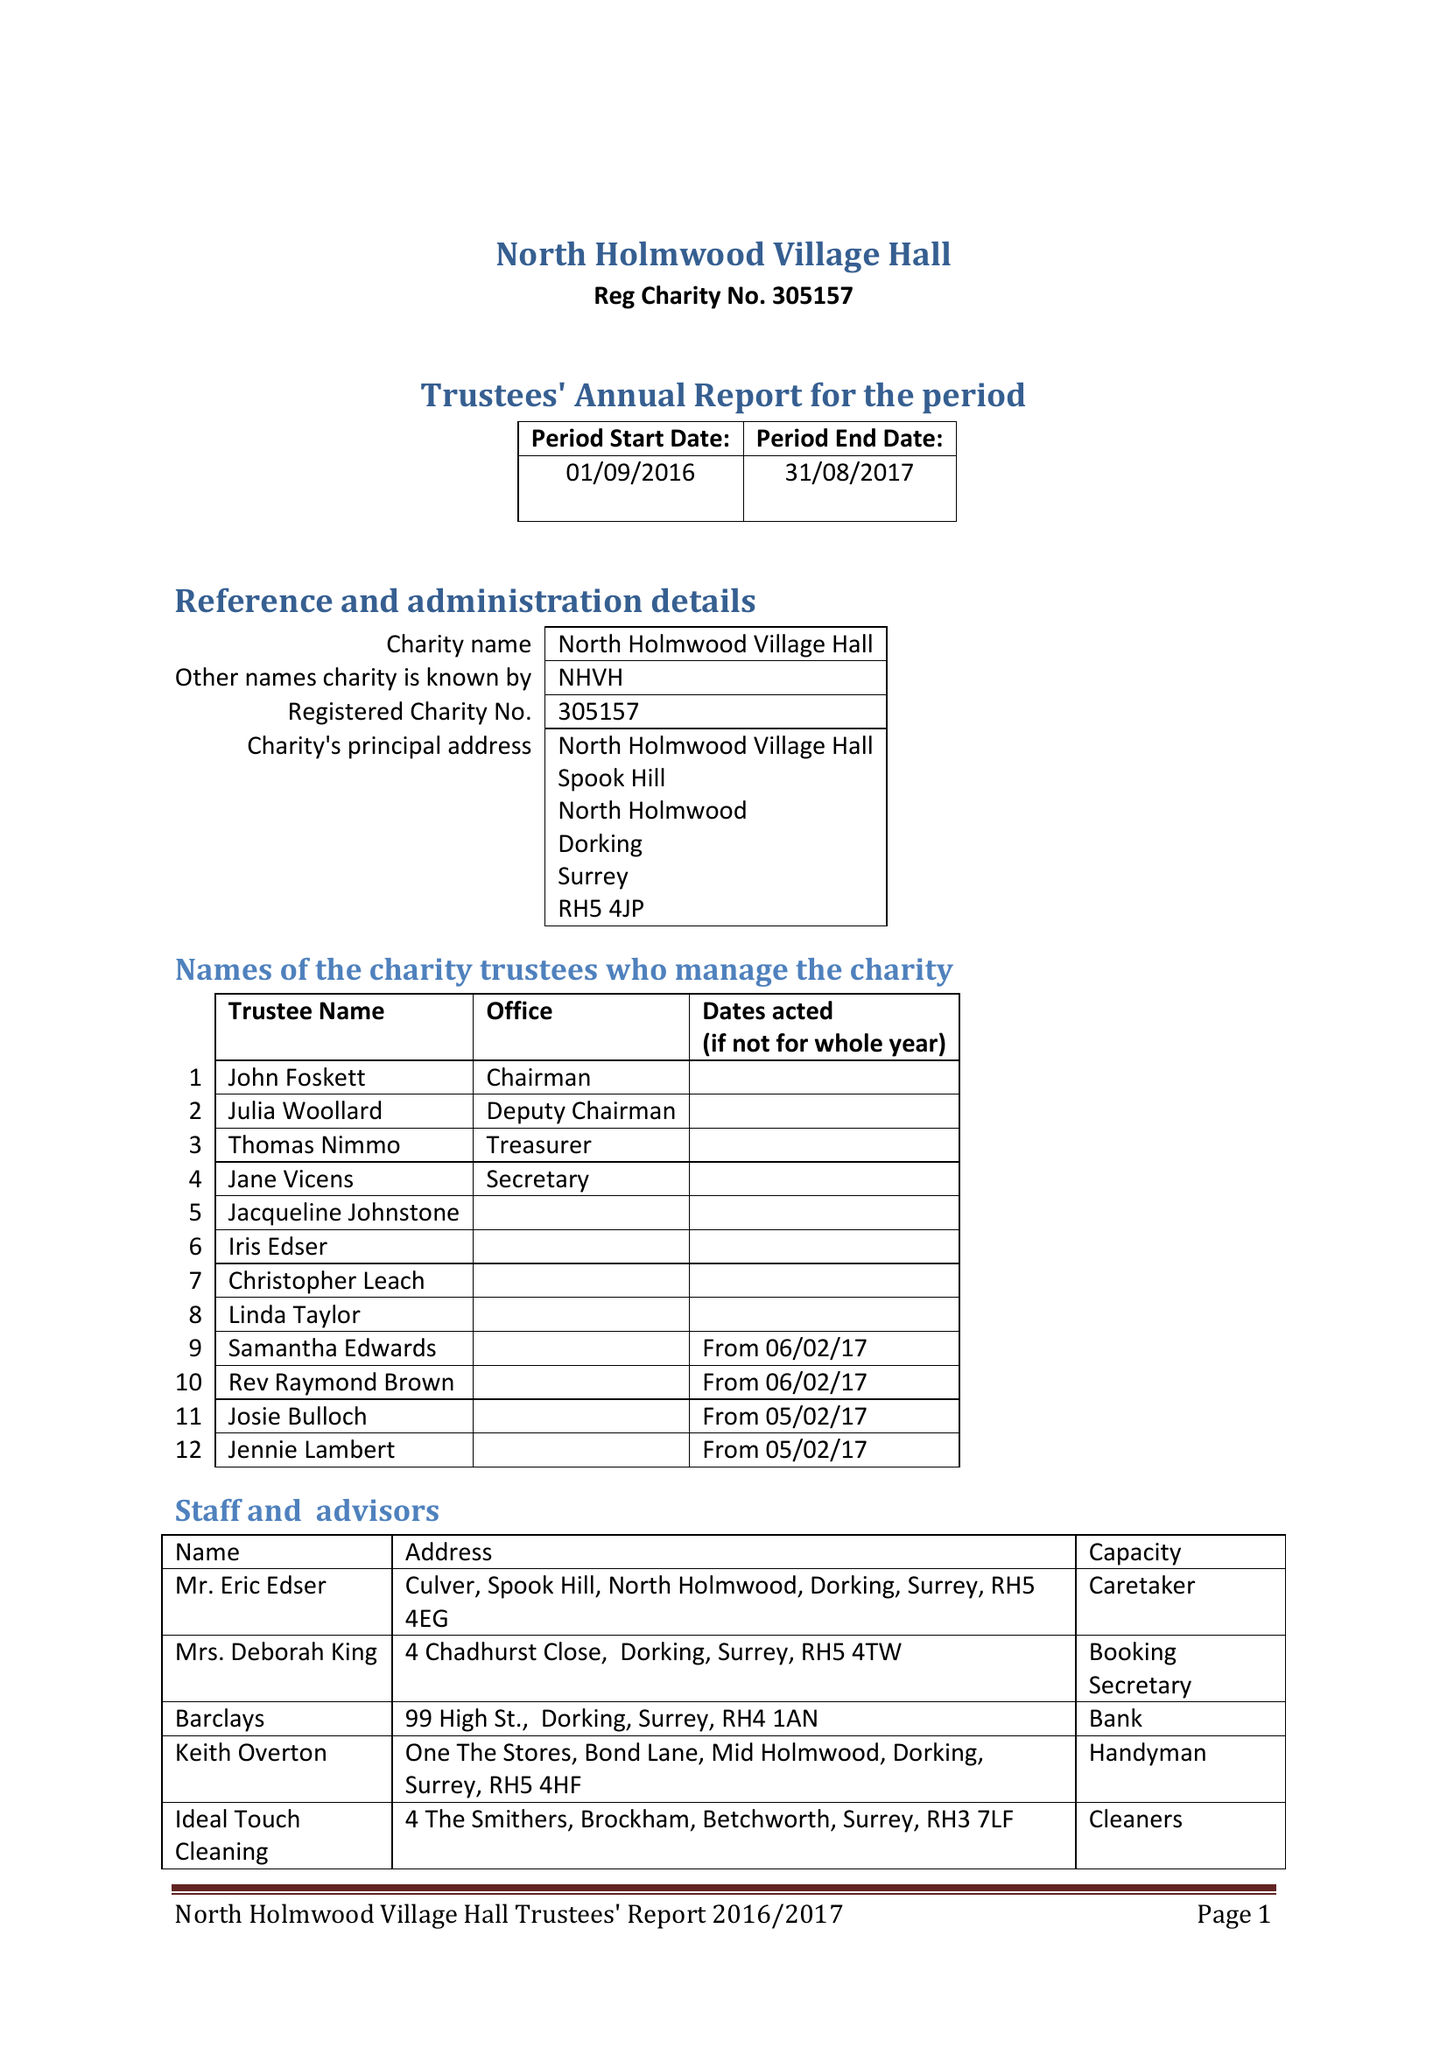What is the value for the report_date?
Answer the question using a single word or phrase. 2017-08-31 